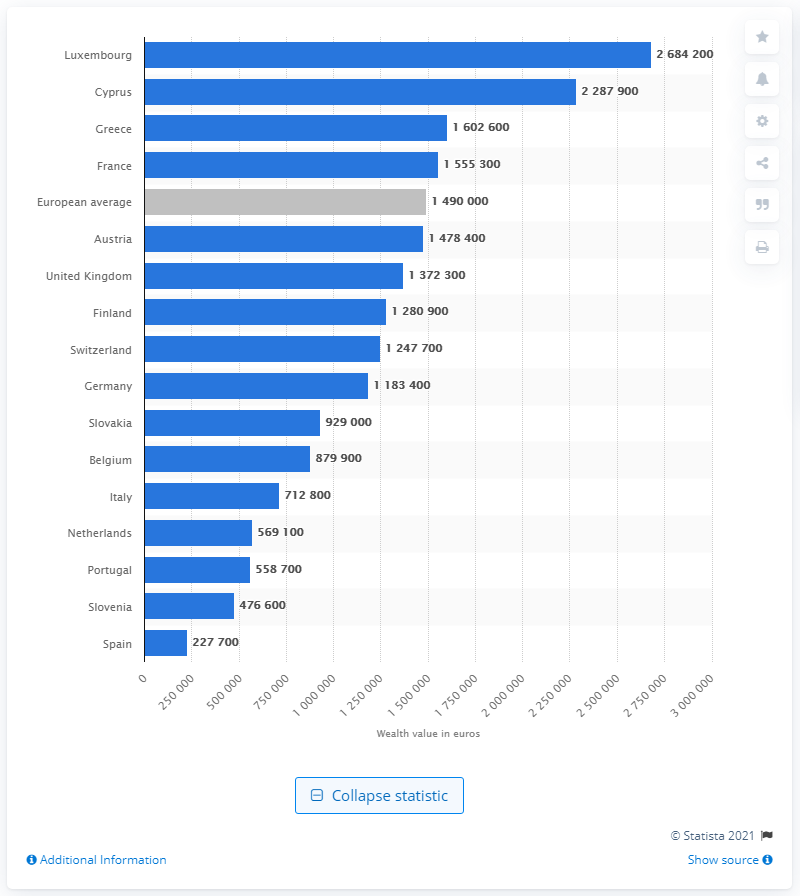List a handful of essential elements in this visual. The cut-off point in Spain in 2014 was 227,700. The starting point for Luxembourg's one percent richest individuals in 2014 was a net worth of 268,420,000. 